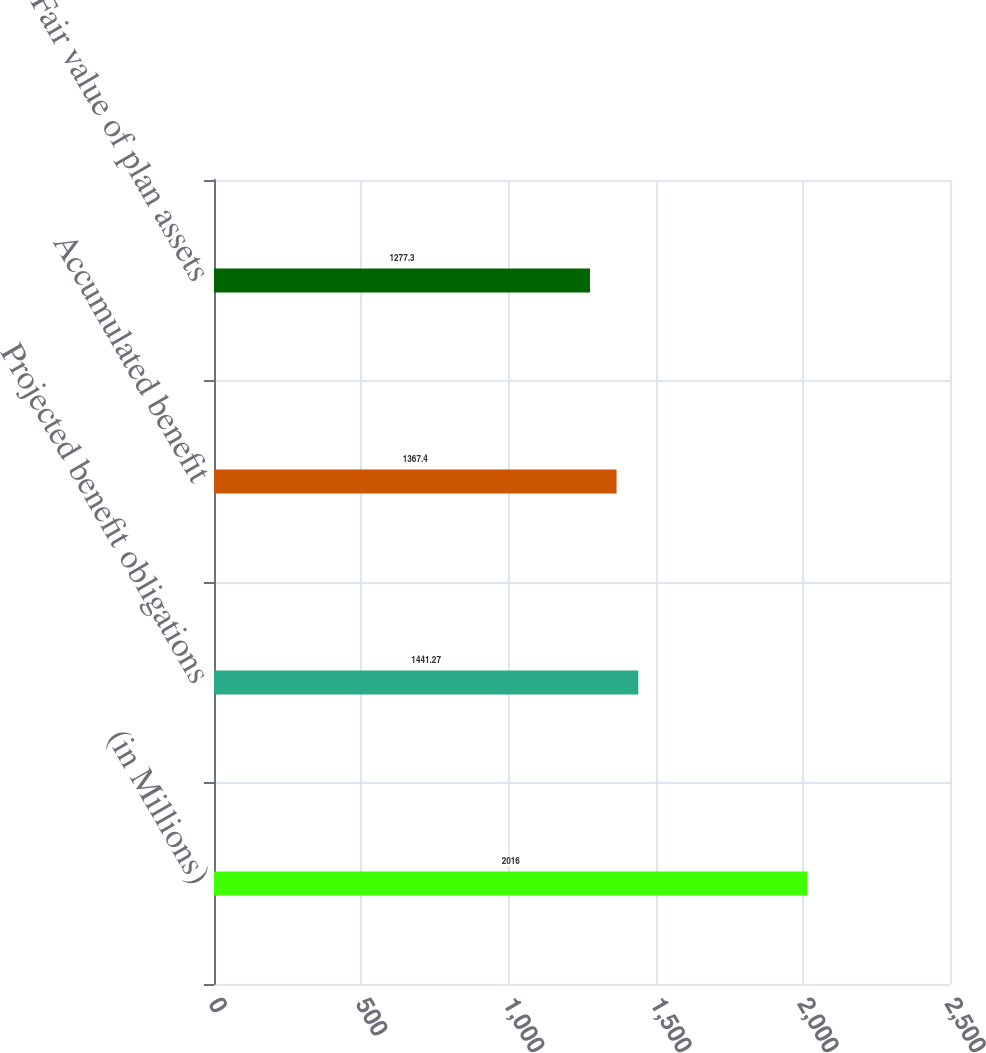Convert chart. <chart><loc_0><loc_0><loc_500><loc_500><bar_chart><fcel>(in Millions)<fcel>Projected benefit obligations<fcel>Accumulated benefit<fcel>Fair value of plan assets<nl><fcel>2016<fcel>1441.27<fcel>1367.4<fcel>1277.3<nl></chart> 